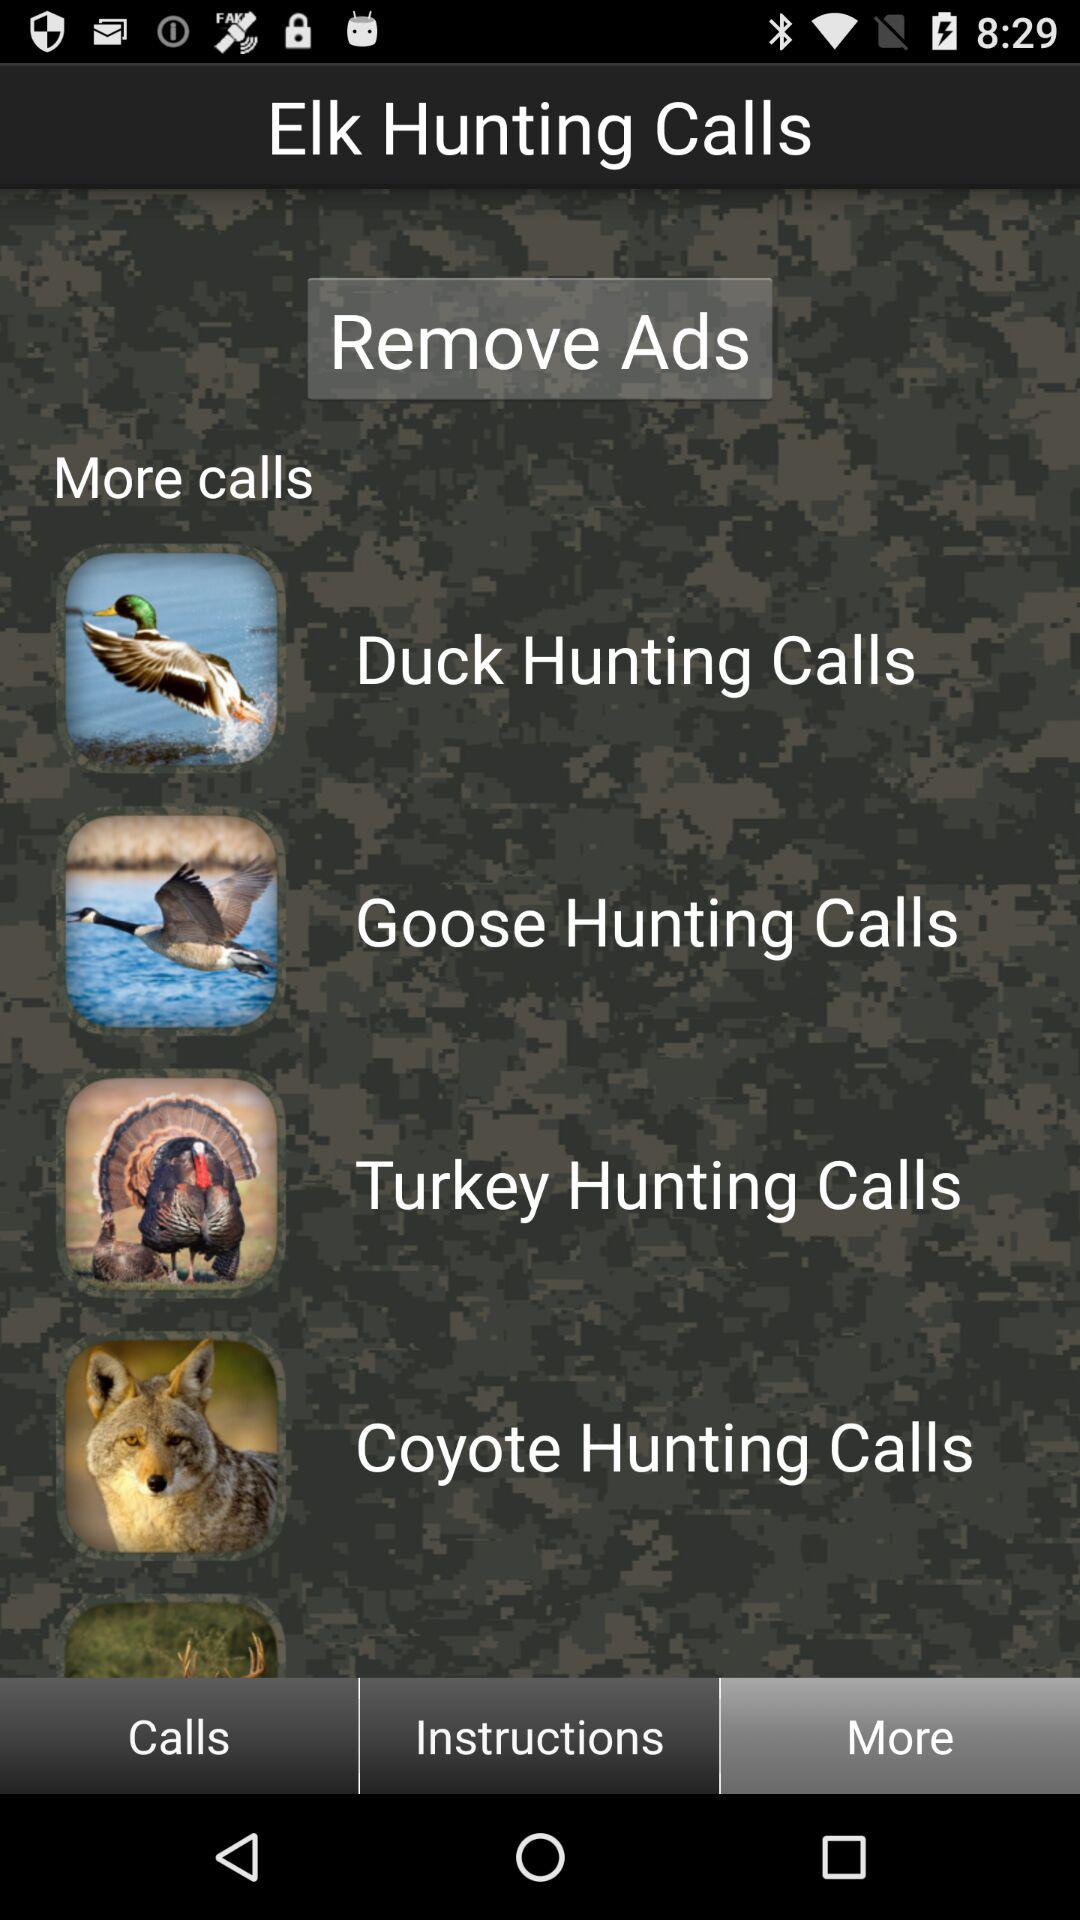What types of calls are available? The types of calls available are: "Elk Hunting Calls", "Duck Hunting Calls", "Goose Hunting Calls", "Turkey Hunting Calls", and "Coyote Hunting Calls". 